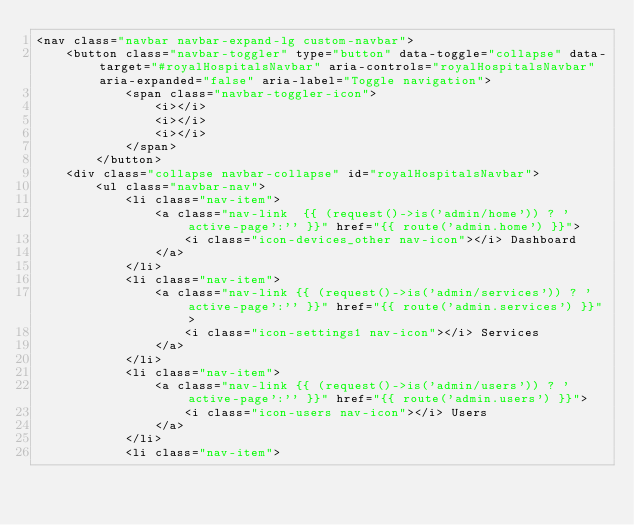Convert code to text. <code><loc_0><loc_0><loc_500><loc_500><_PHP_><nav class="navbar navbar-expand-lg custom-navbar">
    <button class="navbar-toggler" type="button" data-toggle="collapse" data-target="#royalHospitalsNavbar" aria-controls="royalHospitalsNavbar" aria-expanded="false" aria-label="Toggle navigation">
            <span class="navbar-toggler-icon">
                <i></i>
                <i></i>
                <i></i>
            </span>
        </button>
    <div class="collapse navbar-collapse" id="royalHospitalsNavbar">
        <ul class="navbar-nav">
            <li class="nav-item">
                <a class="nav-link  {{ (request()->is('admin/home')) ? 'active-page':'' }}" href="{{ route('admin.home') }}">
                    <i class="icon-devices_other nav-icon"></i> Dashboard
                </a>
            </li>
            <li class="nav-item">
                <a class="nav-link {{ (request()->is('admin/services')) ? 'active-page':'' }}" href="{{ route('admin.services') }}">
                    <i class="icon-settings1 nav-icon"></i> Services
                </a>
            </li>
            <li class="nav-item">
                <a class="nav-link {{ (request()->is('admin/users')) ? 'active-page':'' }}" href="{{ route('admin.users') }}">
                    <i class="icon-users nav-icon"></i> Users
                </a>
            </li>
            <li class="nav-item"></code> 